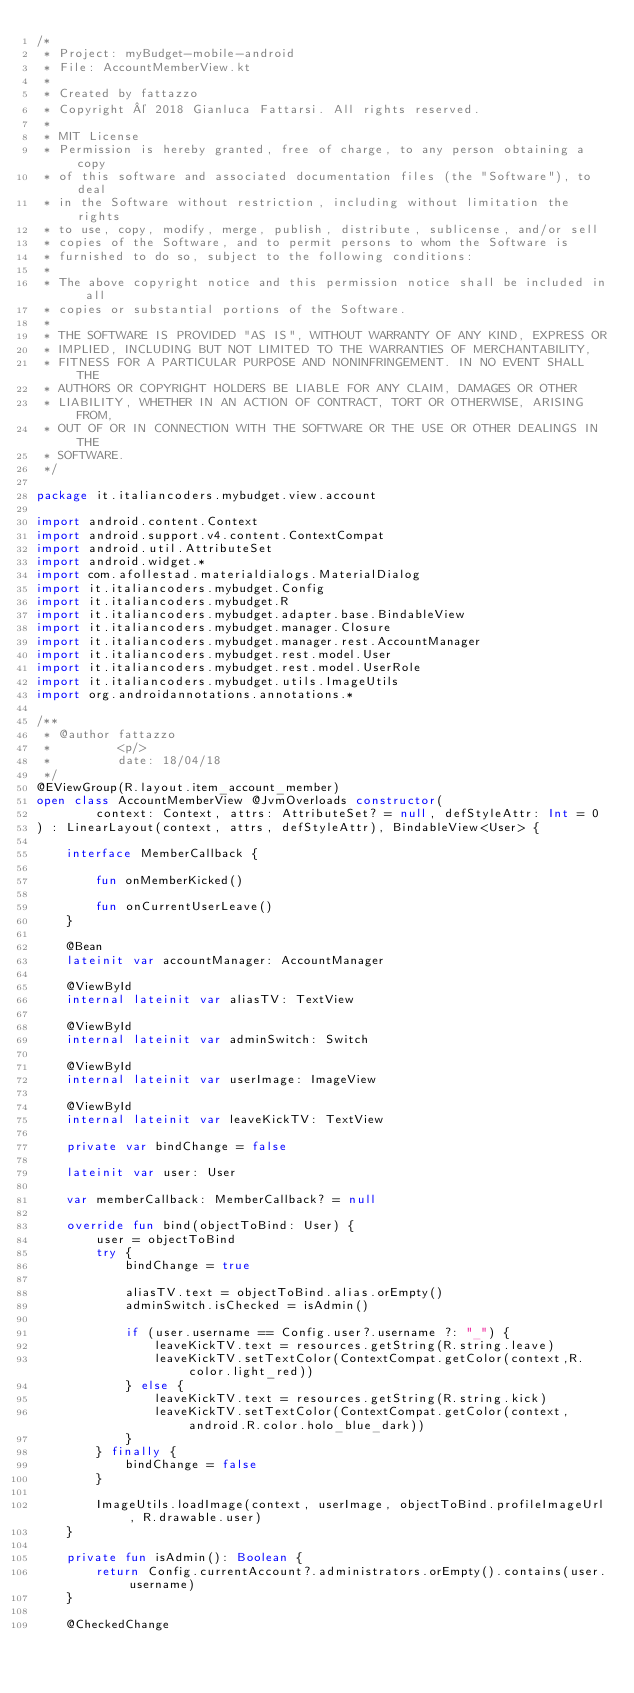Convert code to text. <code><loc_0><loc_0><loc_500><loc_500><_Kotlin_>/*
 * Project: myBudget-mobile-android
 * File: AccountMemberView.kt
 *
 * Created by fattazzo
 * Copyright © 2018 Gianluca Fattarsi. All rights reserved.
 *
 * MIT License
 * Permission is hereby granted, free of charge, to any person obtaining a copy
 * of this software and associated documentation files (the "Software"), to deal
 * in the Software without restriction, including without limitation the rights
 * to use, copy, modify, merge, publish, distribute, sublicense, and/or sell
 * copies of the Software, and to permit persons to whom the Software is
 * furnished to do so, subject to the following conditions:
 *
 * The above copyright notice and this permission notice shall be included in all
 * copies or substantial portions of the Software.
 *
 * THE SOFTWARE IS PROVIDED "AS IS", WITHOUT WARRANTY OF ANY KIND, EXPRESS OR
 * IMPLIED, INCLUDING BUT NOT LIMITED TO THE WARRANTIES OF MERCHANTABILITY,
 * FITNESS FOR A PARTICULAR PURPOSE AND NONINFRINGEMENT. IN NO EVENT SHALL THE
 * AUTHORS OR COPYRIGHT HOLDERS BE LIABLE FOR ANY CLAIM, DAMAGES OR OTHER
 * LIABILITY, WHETHER IN AN ACTION OF CONTRACT, TORT OR OTHERWISE, ARISING FROM,
 * OUT OF OR IN CONNECTION WITH THE SOFTWARE OR THE USE OR OTHER DEALINGS IN THE
 * SOFTWARE.
 */

package it.italiancoders.mybudget.view.account

import android.content.Context
import android.support.v4.content.ContextCompat
import android.util.AttributeSet
import android.widget.*
import com.afollestad.materialdialogs.MaterialDialog
import it.italiancoders.mybudget.Config
import it.italiancoders.mybudget.R
import it.italiancoders.mybudget.adapter.base.BindableView
import it.italiancoders.mybudget.manager.Closure
import it.italiancoders.mybudget.manager.rest.AccountManager
import it.italiancoders.mybudget.rest.model.User
import it.italiancoders.mybudget.rest.model.UserRole
import it.italiancoders.mybudget.utils.ImageUtils
import org.androidannotations.annotations.*

/**
 * @author fattazzo
 *         <p/>
 *         date: 18/04/18
 */
@EViewGroup(R.layout.item_account_member)
open class AccountMemberView @JvmOverloads constructor(
        context: Context, attrs: AttributeSet? = null, defStyleAttr: Int = 0
) : LinearLayout(context, attrs, defStyleAttr), BindableView<User> {

    interface MemberCallback {

        fun onMemberKicked()

        fun onCurrentUserLeave()
    }

    @Bean
    lateinit var accountManager: AccountManager

    @ViewById
    internal lateinit var aliasTV: TextView

    @ViewById
    internal lateinit var adminSwitch: Switch

    @ViewById
    internal lateinit var userImage: ImageView

    @ViewById
    internal lateinit var leaveKickTV: TextView

    private var bindChange = false

    lateinit var user: User

    var memberCallback: MemberCallback? = null

    override fun bind(objectToBind: User) {
        user = objectToBind
        try {
            bindChange = true

            aliasTV.text = objectToBind.alias.orEmpty()
            adminSwitch.isChecked = isAdmin()

            if (user.username == Config.user?.username ?: "_") {
                leaveKickTV.text = resources.getString(R.string.leave)
                leaveKickTV.setTextColor(ContextCompat.getColor(context,R.color.light_red))
            } else {
                leaveKickTV.text = resources.getString(R.string.kick)
                leaveKickTV.setTextColor(ContextCompat.getColor(context,android.R.color.holo_blue_dark))
            }
        } finally {
            bindChange = false
        }

        ImageUtils.loadImage(context, userImage, objectToBind.profileImageUrl, R.drawable.user)
    }

    private fun isAdmin(): Boolean {
        return Config.currentAccount?.administrators.orEmpty().contains(user.username)
    }

    @CheckedChange</code> 